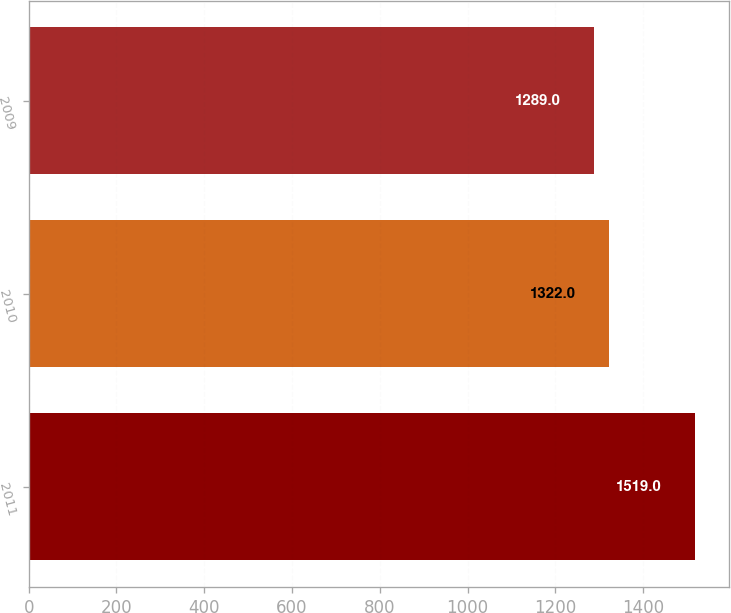<chart> <loc_0><loc_0><loc_500><loc_500><bar_chart><fcel>2011<fcel>2010<fcel>2009<nl><fcel>1519<fcel>1322<fcel>1289<nl></chart> 